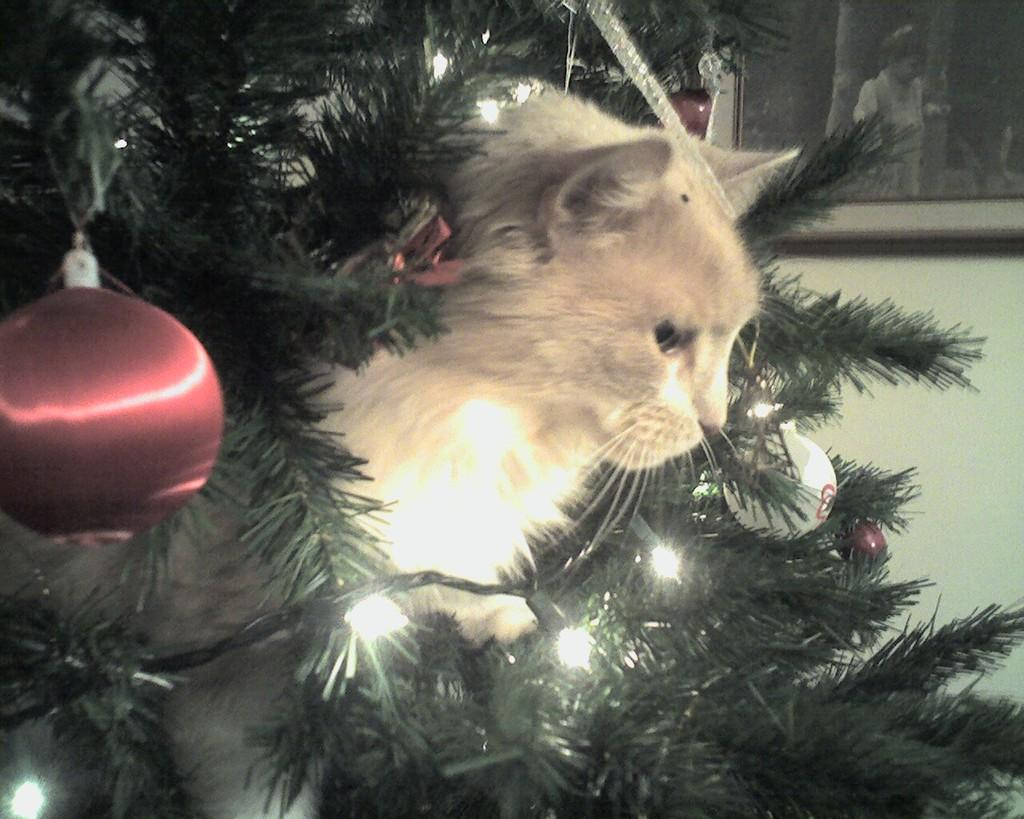What is the main object in the image? There is a Christmas tree in the image. Is there any animal present in the image? Yes, a cat is present between the tree. What decorations are used on the Christmas tree? Beautiful lights are arranged around the tree. How many rings are visible on the cat's tail in the image? There are no rings visible on the cat's tail in the image, as the cat does not have rings on its tail. 